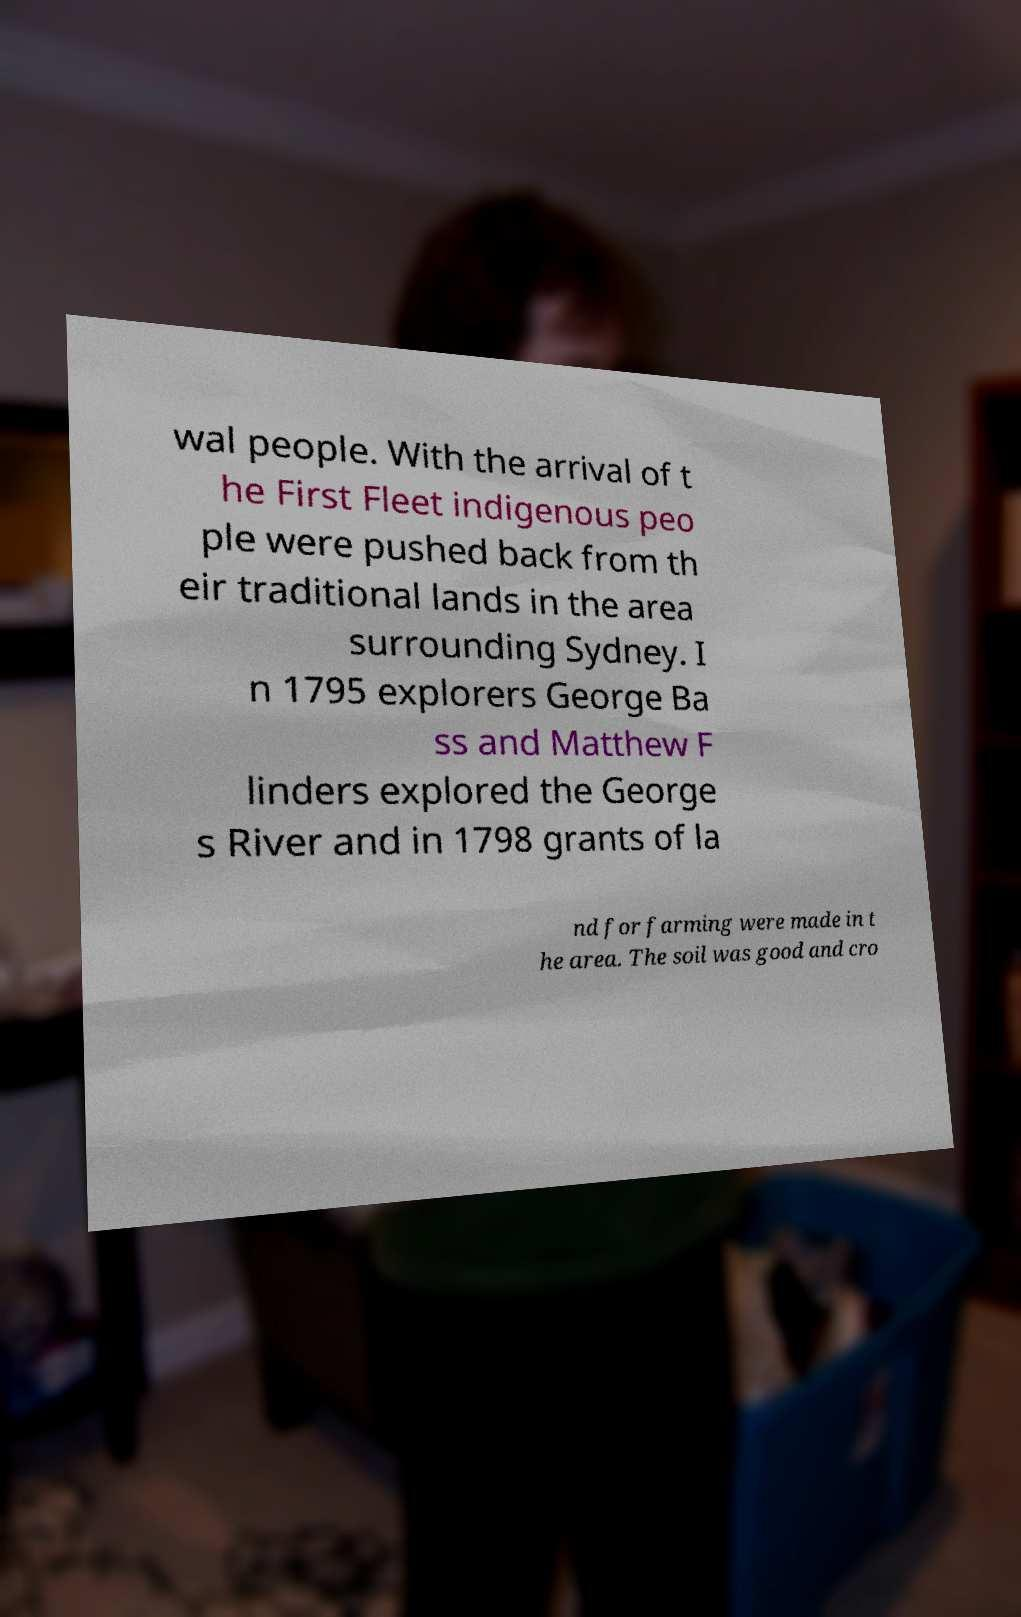For documentation purposes, I need the text within this image transcribed. Could you provide that? wal people. With the arrival of t he First Fleet indigenous peo ple were pushed back from th eir traditional lands in the area surrounding Sydney. I n 1795 explorers George Ba ss and Matthew F linders explored the George s River and in 1798 grants of la nd for farming were made in t he area. The soil was good and cro 